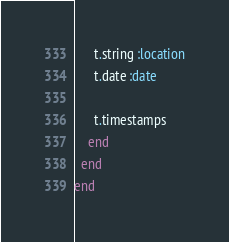<code> <loc_0><loc_0><loc_500><loc_500><_Ruby_>      t.string :location
      t.date :date

      t.timestamps
    end
  end
end
</code> 